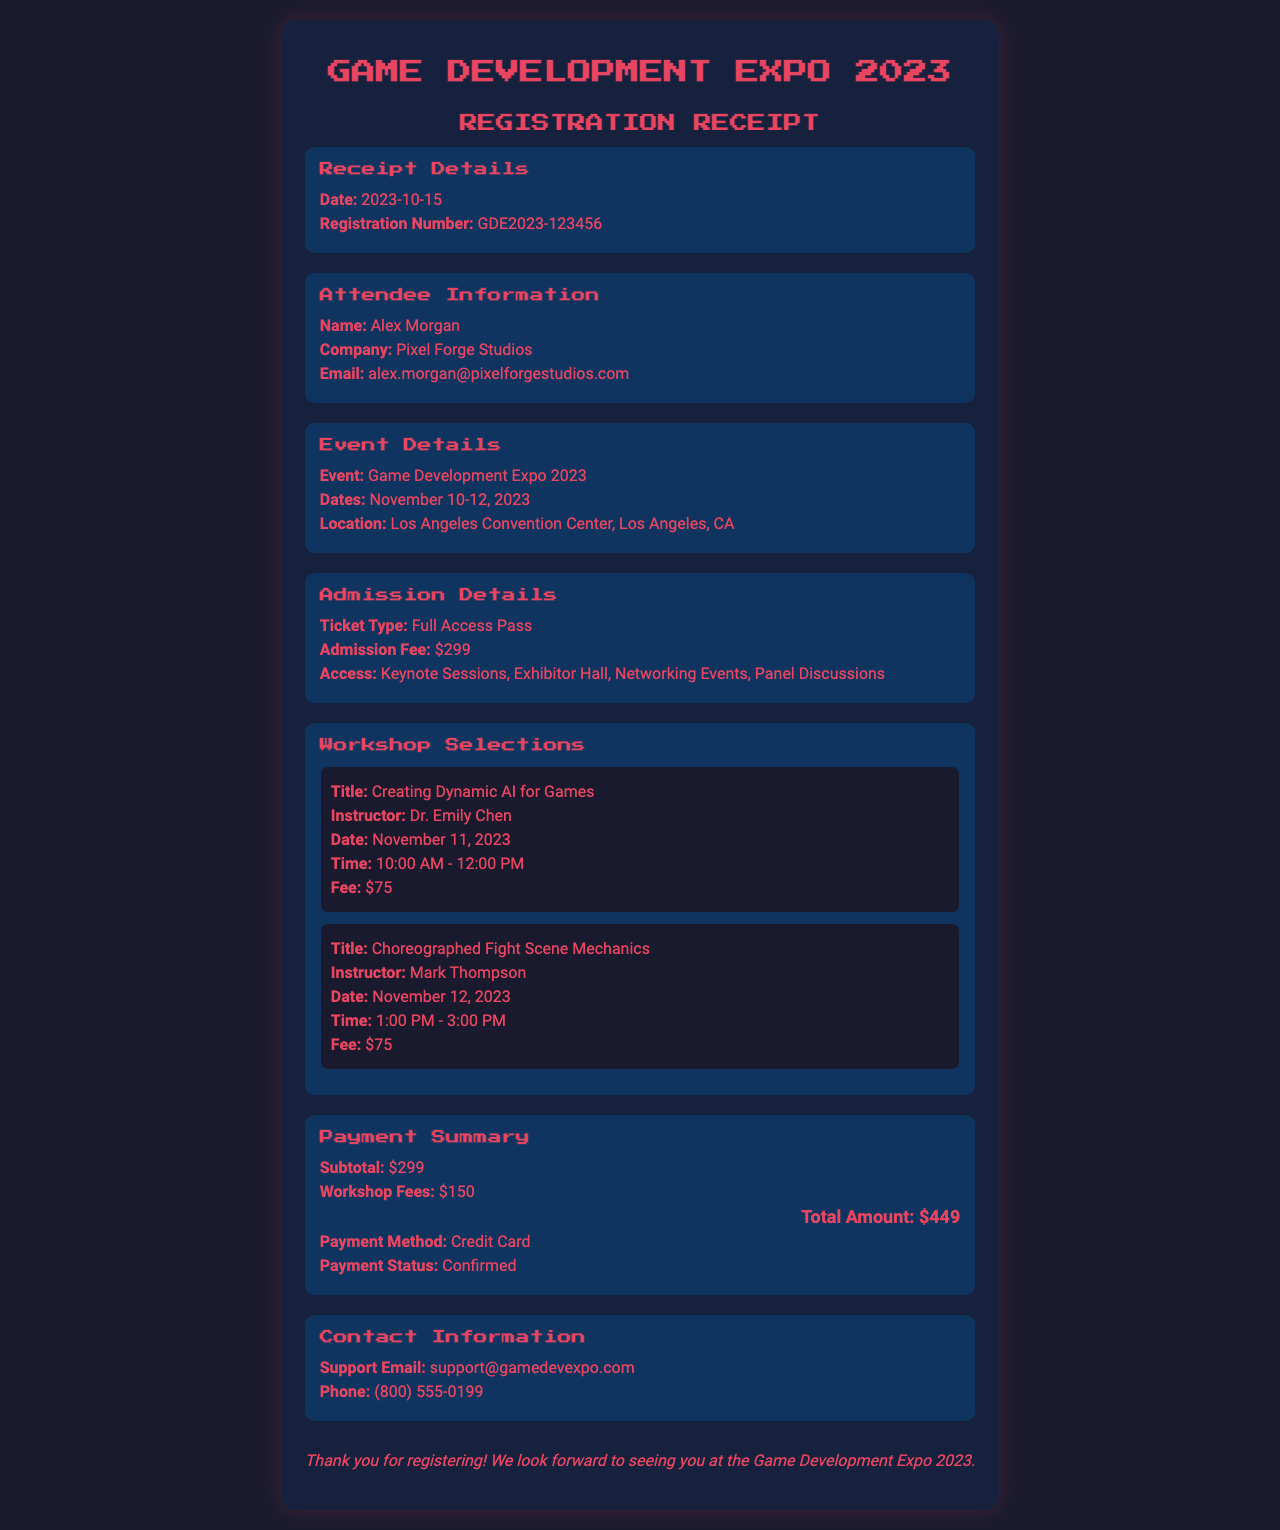What is the date of the receipt? The date is listed under the Receipt Details section of the document as the date when the registration was processed.
Answer: 2023-10-15 What is the registration number? The registration number is provided to uniquely identify the registration record in the Receipt Details section.
Answer: GDE2023-123456 What is the full admission fee? The admission fee is mentioned in the Admission Details section and indicates the cost for the ticket type selected.
Answer: $299 Who is the instructor for the workshop "Creating Dynamic AI for Games"? The instructor's name for this specific workshop is listed in the Workshop Selections section.
Answer: Dr. Emily Chen What is the total amount charged? The total amount is a sum calculated from the subtotal and workshop fees shown in the Payment Summary section.
Answer: $449 What are the dates of the Game Development Expo? The dates are provided in the Event Details section, specifying when the event will take place.
Answer: November 10-12, 2023 What payment method was used? The payment method indicates how the registration fee was settled and is shown in the Payment Summary section.
Answer: Credit Card Which workshop is scheduled for November 12, 2023? The workshop titles are provided along with their respective dates in the Workshop Selections section.
Answer: Choreographed Fight Scene Mechanics What is the support email? The support email is provided in the Contact Information section for inquiries related to the conference.
Answer: support@gamedevexpo.com 